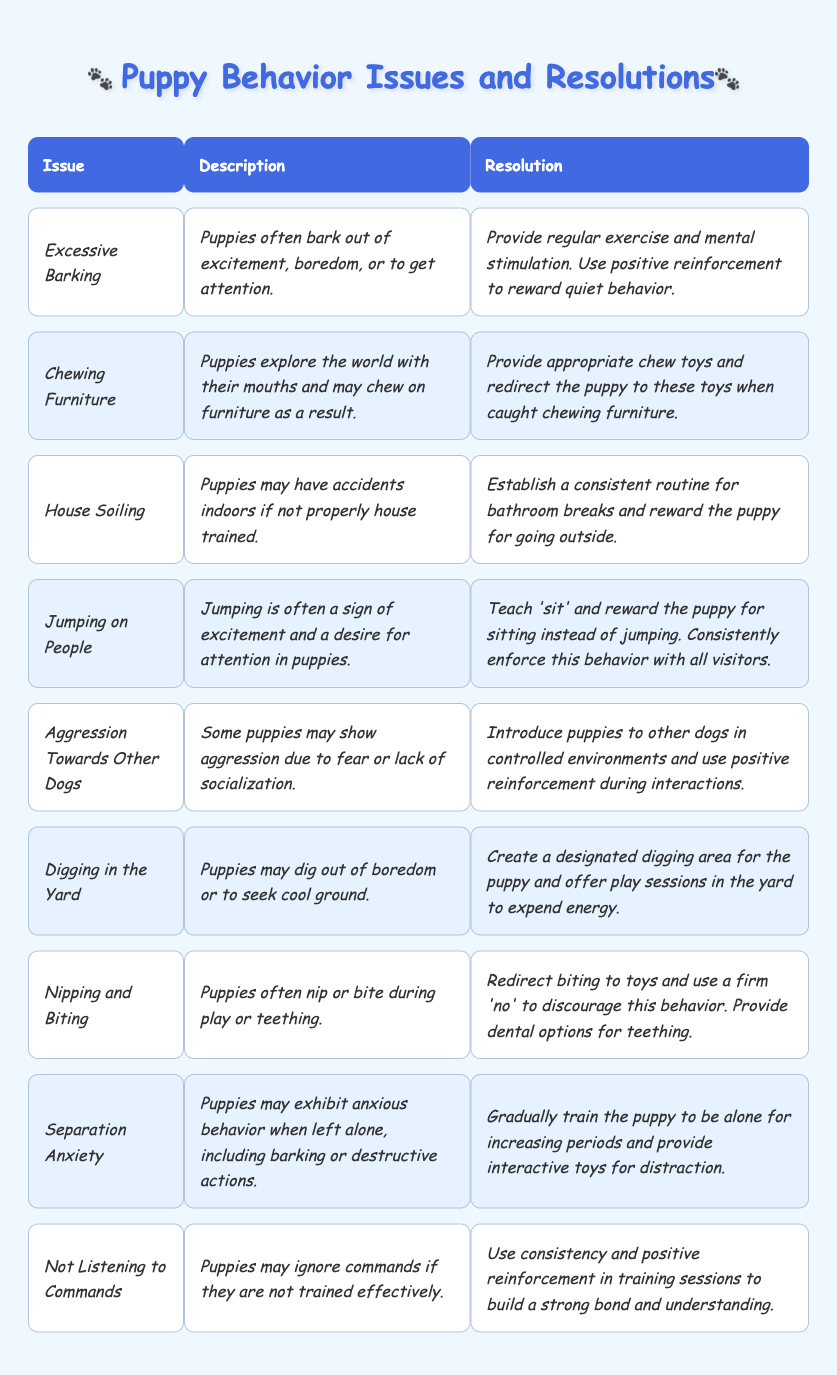What is one common issue related to excessive barking? The table lists "Excessive Barking" as a common puppy behavior issue. The description states that puppies often bark out of excitement, boredom, or to get attention.
Answer: Excessive Barking How can jumping on people be resolved? The resolution provided states to teach the puppy to 'sit' and reward them for this behavior instead of jumping. Consistency in enforcement with all visitors is also advised.
Answer: Teach 'sit' and reward for sitting Is separation anxiety one of the behaviors mentioned? Yes, the table has a specific entry for "Separation Anxiety," indicating it is indeed one of the discussed behaviors.
Answer: Yes What are two causes for puppies chewing on furniture? The description for "Chewing Furniture" mentions that puppies explore the world with their mouths and may chew due to excitement or boredom.
Answer: Excitement and boredom Which issue has a resolution that suggests providing appropriate toys? The issue of "Nipping and Biting" suggests redirecting biting to toys, indicating the importance of providing appropriate toys for puppies.
Answer: Nipping and Biting How does the resolution for house soiling suggest establishing a routine? The resolution advises establishing a consistent routine for bathroom breaks and rewarding the puppy for going outside, which is a method to help with house training.
Answer: Provide a consistent routine for bathroom breaks What behavior issue is associated with fear or lack of socialization? The "Aggression Towards Other Dogs" issue in the table is specifically associated with fear or lack of socialization.
Answer: Aggression Towards Other Dogs Which behavior issue is resolved by offering play sessions in the yard? The issue "Digging in the Yard" mentions creating a designated digging area and offering play sessions to expend the puppy's energy.
Answer: Digging in the Yard What is a shared resolution strategy for both excessive barking and separation anxiety? Both issues suggest providing mental stimulation. For excessive barking, regular exercise and stimulation are advised, while for separation anxiety, interactive toys are recommended for distraction.
Answer: Providing mental stimulation If a puppy is not listening to commands, what training technique should be used? The resolution advises using consistency and positive reinforcement in training sessions to improve the puppy's understanding and responsiveness to commands.
Answer: Consistency and positive reinforcement 